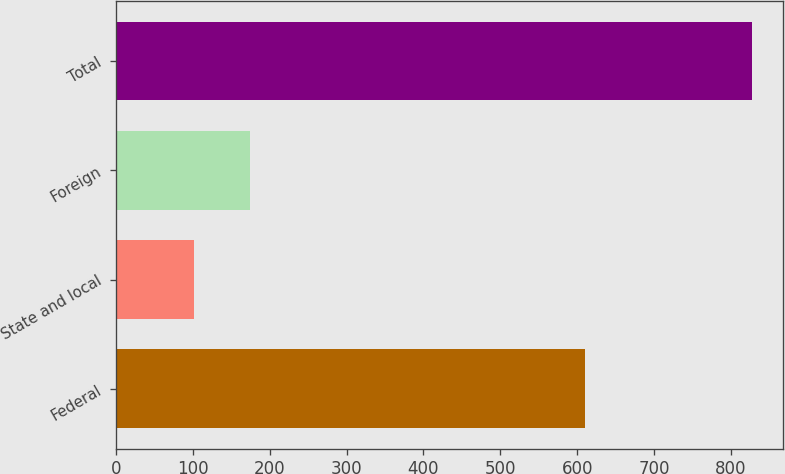Convert chart to OTSL. <chart><loc_0><loc_0><loc_500><loc_500><bar_chart><fcel>Federal<fcel>State and local<fcel>Foreign<fcel>Total<nl><fcel>610<fcel>102<fcel>174.5<fcel>827<nl></chart> 